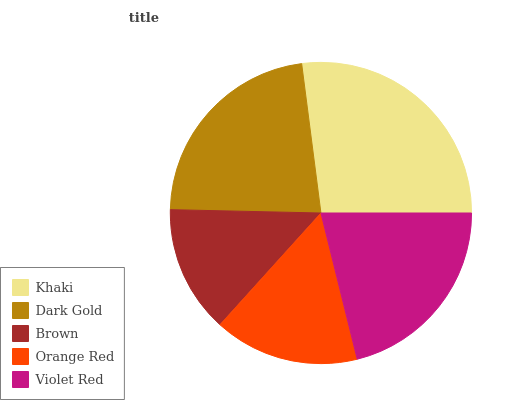Is Brown the minimum?
Answer yes or no. Yes. Is Khaki the maximum?
Answer yes or no. Yes. Is Dark Gold the minimum?
Answer yes or no. No. Is Dark Gold the maximum?
Answer yes or no. No. Is Khaki greater than Dark Gold?
Answer yes or no. Yes. Is Dark Gold less than Khaki?
Answer yes or no. Yes. Is Dark Gold greater than Khaki?
Answer yes or no. No. Is Khaki less than Dark Gold?
Answer yes or no. No. Is Violet Red the high median?
Answer yes or no. Yes. Is Violet Red the low median?
Answer yes or no. Yes. Is Orange Red the high median?
Answer yes or no. No. Is Brown the low median?
Answer yes or no. No. 